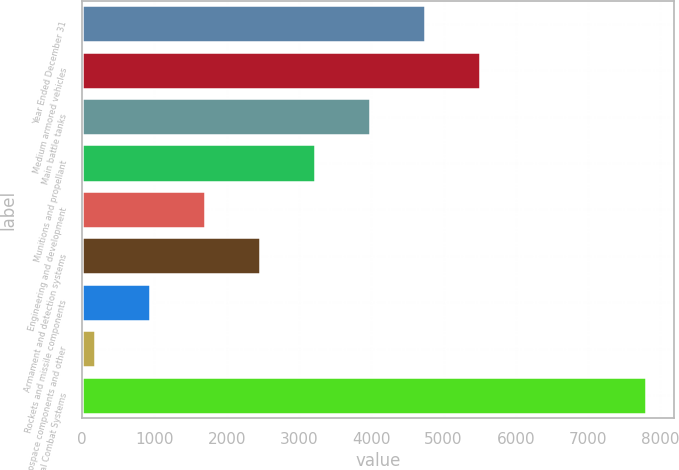<chart> <loc_0><loc_0><loc_500><loc_500><bar_chart><fcel>Year Ended December 31<fcel>Medium armored vehicles<fcel>Main battle tanks<fcel>Munitions and propellant<fcel>Engineering and development<fcel>Armament and detection systems<fcel>Rockets and missile components<fcel>Aerospace components and other<fcel>Total Combat Systems<nl><fcel>4747.4<fcel>5509.8<fcel>3985<fcel>3222.6<fcel>1697.8<fcel>2460.2<fcel>935.4<fcel>173<fcel>7797<nl></chart> 